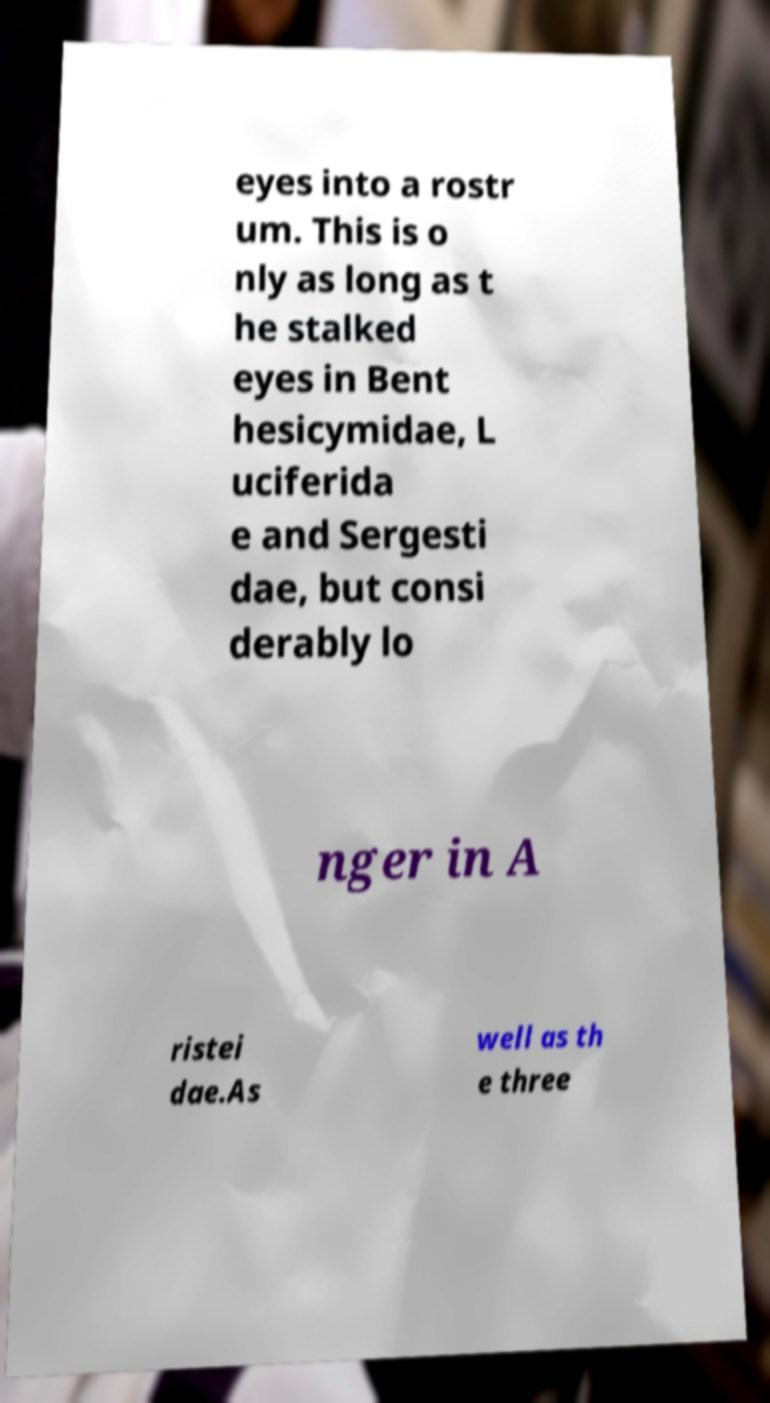Please read and relay the text visible in this image. What does it say? eyes into a rostr um. This is o nly as long as t he stalked eyes in Bent hesicymidae, L uciferida e and Sergesti dae, but consi derably lo nger in A ristei dae.As well as th e three 